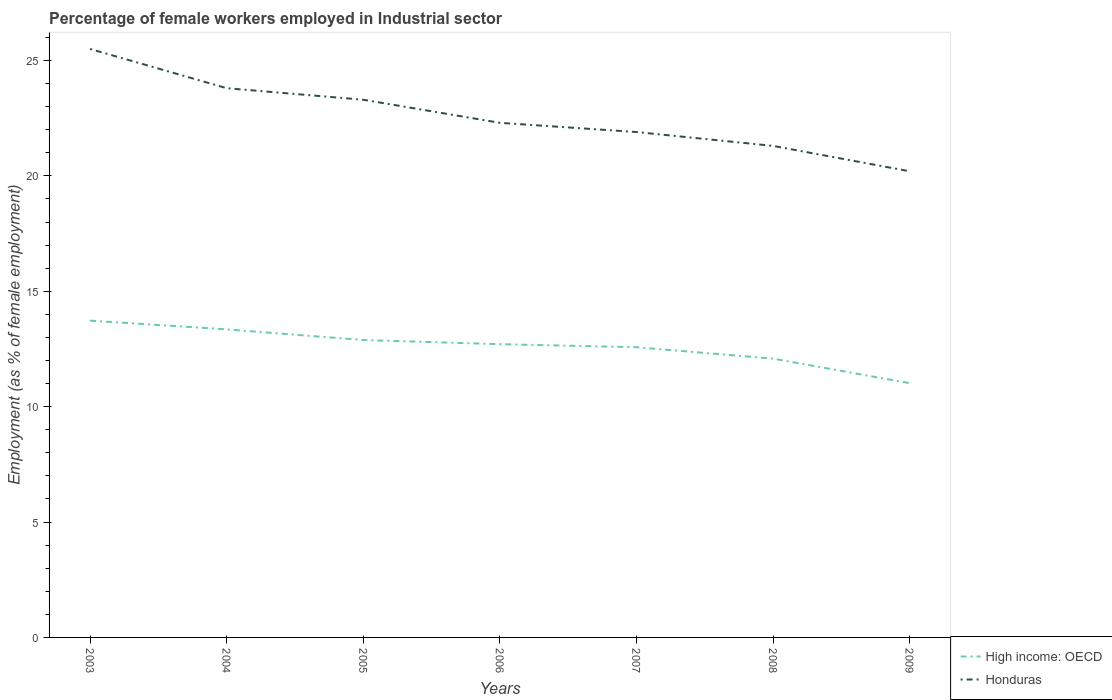How many different coloured lines are there?
Offer a terse response. 2. Is the number of lines equal to the number of legend labels?
Give a very brief answer. Yes. Across all years, what is the maximum percentage of females employed in Industrial sector in Honduras?
Your response must be concise. 20.2. In which year was the percentage of females employed in Industrial sector in High income: OECD maximum?
Provide a short and direct response. 2009. What is the total percentage of females employed in Industrial sector in Honduras in the graph?
Make the answer very short. 4.2. What is the difference between the highest and the second highest percentage of females employed in Industrial sector in High income: OECD?
Ensure brevity in your answer.  2.71. What is the difference between the highest and the lowest percentage of females employed in Industrial sector in High income: OECD?
Keep it short and to the point. 4. How many lines are there?
Make the answer very short. 2. What is the difference between two consecutive major ticks on the Y-axis?
Your answer should be very brief. 5. Where does the legend appear in the graph?
Give a very brief answer. Bottom right. What is the title of the graph?
Give a very brief answer. Percentage of female workers employed in Industrial sector. What is the label or title of the Y-axis?
Provide a short and direct response. Employment (as % of female employment). What is the Employment (as % of female employment) in High income: OECD in 2003?
Your answer should be very brief. 13.73. What is the Employment (as % of female employment) in High income: OECD in 2004?
Make the answer very short. 13.35. What is the Employment (as % of female employment) of Honduras in 2004?
Your response must be concise. 23.8. What is the Employment (as % of female employment) of High income: OECD in 2005?
Ensure brevity in your answer.  12.89. What is the Employment (as % of female employment) in Honduras in 2005?
Make the answer very short. 23.3. What is the Employment (as % of female employment) in High income: OECD in 2006?
Provide a succinct answer. 12.71. What is the Employment (as % of female employment) of Honduras in 2006?
Offer a very short reply. 22.3. What is the Employment (as % of female employment) of High income: OECD in 2007?
Your answer should be very brief. 12.58. What is the Employment (as % of female employment) of Honduras in 2007?
Offer a terse response. 21.9. What is the Employment (as % of female employment) of High income: OECD in 2008?
Offer a terse response. 12.08. What is the Employment (as % of female employment) of Honduras in 2008?
Your answer should be very brief. 21.3. What is the Employment (as % of female employment) in High income: OECD in 2009?
Your response must be concise. 11.02. What is the Employment (as % of female employment) in Honduras in 2009?
Your answer should be very brief. 20.2. Across all years, what is the maximum Employment (as % of female employment) of High income: OECD?
Make the answer very short. 13.73. Across all years, what is the maximum Employment (as % of female employment) in Honduras?
Offer a terse response. 25.5. Across all years, what is the minimum Employment (as % of female employment) of High income: OECD?
Offer a very short reply. 11.02. Across all years, what is the minimum Employment (as % of female employment) of Honduras?
Your answer should be compact. 20.2. What is the total Employment (as % of female employment) of High income: OECD in the graph?
Make the answer very short. 88.34. What is the total Employment (as % of female employment) in Honduras in the graph?
Keep it short and to the point. 158.3. What is the difference between the Employment (as % of female employment) in High income: OECD in 2003 and that in 2004?
Give a very brief answer. 0.38. What is the difference between the Employment (as % of female employment) in Honduras in 2003 and that in 2004?
Provide a succinct answer. 1.7. What is the difference between the Employment (as % of female employment) of High income: OECD in 2003 and that in 2005?
Provide a succinct answer. 0.84. What is the difference between the Employment (as % of female employment) of High income: OECD in 2003 and that in 2006?
Provide a succinct answer. 1.02. What is the difference between the Employment (as % of female employment) in Honduras in 2003 and that in 2006?
Provide a short and direct response. 3.2. What is the difference between the Employment (as % of female employment) of High income: OECD in 2003 and that in 2007?
Your answer should be very brief. 1.15. What is the difference between the Employment (as % of female employment) in Honduras in 2003 and that in 2007?
Make the answer very short. 3.6. What is the difference between the Employment (as % of female employment) in High income: OECD in 2003 and that in 2008?
Ensure brevity in your answer.  1.65. What is the difference between the Employment (as % of female employment) in Honduras in 2003 and that in 2008?
Make the answer very short. 4.2. What is the difference between the Employment (as % of female employment) of High income: OECD in 2003 and that in 2009?
Offer a terse response. 2.71. What is the difference between the Employment (as % of female employment) in Honduras in 2003 and that in 2009?
Ensure brevity in your answer.  5.3. What is the difference between the Employment (as % of female employment) in High income: OECD in 2004 and that in 2005?
Keep it short and to the point. 0.46. What is the difference between the Employment (as % of female employment) in Honduras in 2004 and that in 2005?
Give a very brief answer. 0.5. What is the difference between the Employment (as % of female employment) of High income: OECD in 2004 and that in 2006?
Provide a succinct answer. 0.64. What is the difference between the Employment (as % of female employment) in High income: OECD in 2004 and that in 2007?
Your answer should be compact. 0.77. What is the difference between the Employment (as % of female employment) in Honduras in 2004 and that in 2007?
Keep it short and to the point. 1.9. What is the difference between the Employment (as % of female employment) in High income: OECD in 2004 and that in 2008?
Your answer should be compact. 1.27. What is the difference between the Employment (as % of female employment) of Honduras in 2004 and that in 2008?
Provide a succinct answer. 2.5. What is the difference between the Employment (as % of female employment) of High income: OECD in 2004 and that in 2009?
Ensure brevity in your answer.  2.33. What is the difference between the Employment (as % of female employment) of High income: OECD in 2005 and that in 2006?
Offer a very short reply. 0.18. What is the difference between the Employment (as % of female employment) in High income: OECD in 2005 and that in 2007?
Your answer should be very brief. 0.31. What is the difference between the Employment (as % of female employment) in High income: OECD in 2005 and that in 2008?
Offer a very short reply. 0.81. What is the difference between the Employment (as % of female employment) in Honduras in 2005 and that in 2008?
Your answer should be very brief. 2. What is the difference between the Employment (as % of female employment) of High income: OECD in 2005 and that in 2009?
Offer a terse response. 1.87. What is the difference between the Employment (as % of female employment) of High income: OECD in 2006 and that in 2007?
Offer a very short reply. 0.13. What is the difference between the Employment (as % of female employment) of Honduras in 2006 and that in 2007?
Keep it short and to the point. 0.4. What is the difference between the Employment (as % of female employment) of High income: OECD in 2006 and that in 2008?
Ensure brevity in your answer.  0.63. What is the difference between the Employment (as % of female employment) of High income: OECD in 2006 and that in 2009?
Give a very brief answer. 1.69. What is the difference between the Employment (as % of female employment) in High income: OECD in 2007 and that in 2008?
Your answer should be compact. 0.49. What is the difference between the Employment (as % of female employment) in Honduras in 2007 and that in 2008?
Keep it short and to the point. 0.6. What is the difference between the Employment (as % of female employment) of High income: OECD in 2007 and that in 2009?
Provide a short and direct response. 1.56. What is the difference between the Employment (as % of female employment) in Honduras in 2007 and that in 2009?
Offer a very short reply. 1.7. What is the difference between the Employment (as % of female employment) of High income: OECD in 2008 and that in 2009?
Offer a terse response. 1.06. What is the difference between the Employment (as % of female employment) in Honduras in 2008 and that in 2009?
Your response must be concise. 1.1. What is the difference between the Employment (as % of female employment) in High income: OECD in 2003 and the Employment (as % of female employment) in Honduras in 2004?
Offer a terse response. -10.07. What is the difference between the Employment (as % of female employment) of High income: OECD in 2003 and the Employment (as % of female employment) of Honduras in 2005?
Ensure brevity in your answer.  -9.57. What is the difference between the Employment (as % of female employment) in High income: OECD in 2003 and the Employment (as % of female employment) in Honduras in 2006?
Ensure brevity in your answer.  -8.57. What is the difference between the Employment (as % of female employment) in High income: OECD in 2003 and the Employment (as % of female employment) in Honduras in 2007?
Offer a very short reply. -8.17. What is the difference between the Employment (as % of female employment) in High income: OECD in 2003 and the Employment (as % of female employment) in Honduras in 2008?
Offer a very short reply. -7.57. What is the difference between the Employment (as % of female employment) in High income: OECD in 2003 and the Employment (as % of female employment) in Honduras in 2009?
Provide a succinct answer. -6.47. What is the difference between the Employment (as % of female employment) in High income: OECD in 2004 and the Employment (as % of female employment) in Honduras in 2005?
Ensure brevity in your answer.  -9.95. What is the difference between the Employment (as % of female employment) of High income: OECD in 2004 and the Employment (as % of female employment) of Honduras in 2006?
Give a very brief answer. -8.95. What is the difference between the Employment (as % of female employment) of High income: OECD in 2004 and the Employment (as % of female employment) of Honduras in 2007?
Ensure brevity in your answer.  -8.55. What is the difference between the Employment (as % of female employment) in High income: OECD in 2004 and the Employment (as % of female employment) in Honduras in 2008?
Provide a short and direct response. -7.95. What is the difference between the Employment (as % of female employment) in High income: OECD in 2004 and the Employment (as % of female employment) in Honduras in 2009?
Ensure brevity in your answer.  -6.85. What is the difference between the Employment (as % of female employment) in High income: OECD in 2005 and the Employment (as % of female employment) in Honduras in 2006?
Your answer should be very brief. -9.41. What is the difference between the Employment (as % of female employment) of High income: OECD in 2005 and the Employment (as % of female employment) of Honduras in 2007?
Your answer should be very brief. -9.01. What is the difference between the Employment (as % of female employment) of High income: OECD in 2005 and the Employment (as % of female employment) of Honduras in 2008?
Make the answer very short. -8.41. What is the difference between the Employment (as % of female employment) of High income: OECD in 2005 and the Employment (as % of female employment) of Honduras in 2009?
Your answer should be compact. -7.31. What is the difference between the Employment (as % of female employment) of High income: OECD in 2006 and the Employment (as % of female employment) of Honduras in 2007?
Offer a terse response. -9.19. What is the difference between the Employment (as % of female employment) of High income: OECD in 2006 and the Employment (as % of female employment) of Honduras in 2008?
Keep it short and to the point. -8.59. What is the difference between the Employment (as % of female employment) of High income: OECD in 2006 and the Employment (as % of female employment) of Honduras in 2009?
Provide a succinct answer. -7.49. What is the difference between the Employment (as % of female employment) of High income: OECD in 2007 and the Employment (as % of female employment) of Honduras in 2008?
Offer a terse response. -8.72. What is the difference between the Employment (as % of female employment) of High income: OECD in 2007 and the Employment (as % of female employment) of Honduras in 2009?
Your answer should be compact. -7.62. What is the difference between the Employment (as % of female employment) in High income: OECD in 2008 and the Employment (as % of female employment) in Honduras in 2009?
Make the answer very short. -8.12. What is the average Employment (as % of female employment) of High income: OECD per year?
Give a very brief answer. 12.62. What is the average Employment (as % of female employment) in Honduras per year?
Ensure brevity in your answer.  22.61. In the year 2003, what is the difference between the Employment (as % of female employment) in High income: OECD and Employment (as % of female employment) in Honduras?
Offer a terse response. -11.77. In the year 2004, what is the difference between the Employment (as % of female employment) in High income: OECD and Employment (as % of female employment) in Honduras?
Your response must be concise. -10.45. In the year 2005, what is the difference between the Employment (as % of female employment) in High income: OECD and Employment (as % of female employment) in Honduras?
Offer a very short reply. -10.41. In the year 2006, what is the difference between the Employment (as % of female employment) of High income: OECD and Employment (as % of female employment) of Honduras?
Provide a short and direct response. -9.59. In the year 2007, what is the difference between the Employment (as % of female employment) in High income: OECD and Employment (as % of female employment) in Honduras?
Offer a very short reply. -9.32. In the year 2008, what is the difference between the Employment (as % of female employment) of High income: OECD and Employment (as % of female employment) of Honduras?
Your response must be concise. -9.22. In the year 2009, what is the difference between the Employment (as % of female employment) in High income: OECD and Employment (as % of female employment) in Honduras?
Ensure brevity in your answer.  -9.18. What is the ratio of the Employment (as % of female employment) in High income: OECD in 2003 to that in 2004?
Your answer should be compact. 1.03. What is the ratio of the Employment (as % of female employment) of Honduras in 2003 to that in 2004?
Provide a succinct answer. 1.07. What is the ratio of the Employment (as % of female employment) of High income: OECD in 2003 to that in 2005?
Ensure brevity in your answer.  1.07. What is the ratio of the Employment (as % of female employment) in Honduras in 2003 to that in 2005?
Provide a succinct answer. 1.09. What is the ratio of the Employment (as % of female employment) of High income: OECD in 2003 to that in 2006?
Keep it short and to the point. 1.08. What is the ratio of the Employment (as % of female employment) of Honduras in 2003 to that in 2006?
Offer a very short reply. 1.14. What is the ratio of the Employment (as % of female employment) of High income: OECD in 2003 to that in 2007?
Provide a succinct answer. 1.09. What is the ratio of the Employment (as % of female employment) in Honduras in 2003 to that in 2007?
Offer a terse response. 1.16. What is the ratio of the Employment (as % of female employment) of High income: OECD in 2003 to that in 2008?
Your response must be concise. 1.14. What is the ratio of the Employment (as % of female employment) in Honduras in 2003 to that in 2008?
Offer a very short reply. 1.2. What is the ratio of the Employment (as % of female employment) in High income: OECD in 2003 to that in 2009?
Offer a terse response. 1.25. What is the ratio of the Employment (as % of female employment) in Honduras in 2003 to that in 2009?
Your answer should be compact. 1.26. What is the ratio of the Employment (as % of female employment) in High income: OECD in 2004 to that in 2005?
Your answer should be compact. 1.04. What is the ratio of the Employment (as % of female employment) of Honduras in 2004 to that in 2005?
Your answer should be very brief. 1.02. What is the ratio of the Employment (as % of female employment) in High income: OECD in 2004 to that in 2006?
Provide a succinct answer. 1.05. What is the ratio of the Employment (as % of female employment) in Honduras in 2004 to that in 2006?
Offer a terse response. 1.07. What is the ratio of the Employment (as % of female employment) of High income: OECD in 2004 to that in 2007?
Your response must be concise. 1.06. What is the ratio of the Employment (as % of female employment) in Honduras in 2004 to that in 2007?
Offer a terse response. 1.09. What is the ratio of the Employment (as % of female employment) in High income: OECD in 2004 to that in 2008?
Your answer should be compact. 1.1. What is the ratio of the Employment (as % of female employment) in Honduras in 2004 to that in 2008?
Give a very brief answer. 1.12. What is the ratio of the Employment (as % of female employment) of High income: OECD in 2004 to that in 2009?
Your answer should be very brief. 1.21. What is the ratio of the Employment (as % of female employment) of Honduras in 2004 to that in 2009?
Ensure brevity in your answer.  1.18. What is the ratio of the Employment (as % of female employment) of High income: OECD in 2005 to that in 2006?
Give a very brief answer. 1.01. What is the ratio of the Employment (as % of female employment) of Honduras in 2005 to that in 2006?
Provide a succinct answer. 1.04. What is the ratio of the Employment (as % of female employment) in High income: OECD in 2005 to that in 2007?
Provide a short and direct response. 1.02. What is the ratio of the Employment (as % of female employment) in Honduras in 2005 to that in 2007?
Provide a succinct answer. 1.06. What is the ratio of the Employment (as % of female employment) in High income: OECD in 2005 to that in 2008?
Your response must be concise. 1.07. What is the ratio of the Employment (as % of female employment) in Honduras in 2005 to that in 2008?
Offer a very short reply. 1.09. What is the ratio of the Employment (as % of female employment) of High income: OECD in 2005 to that in 2009?
Your answer should be compact. 1.17. What is the ratio of the Employment (as % of female employment) in Honduras in 2005 to that in 2009?
Your answer should be compact. 1.15. What is the ratio of the Employment (as % of female employment) in High income: OECD in 2006 to that in 2007?
Keep it short and to the point. 1.01. What is the ratio of the Employment (as % of female employment) of Honduras in 2006 to that in 2007?
Ensure brevity in your answer.  1.02. What is the ratio of the Employment (as % of female employment) in High income: OECD in 2006 to that in 2008?
Make the answer very short. 1.05. What is the ratio of the Employment (as % of female employment) of Honduras in 2006 to that in 2008?
Offer a terse response. 1.05. What is the ratio of the Employment (as % of female employment) of High income: OECD in 2006 to that in 2009?
Offer a very short reply. 1.15. What is the ratio of the Employment (as % of female employment) of Honduras in 2006 to that in 2009?
Keep it short and to the point. 1.1. What is the ratio of the Employment (as % of female employment) of High income: OECD in 2007 to that in 2008?
Your answer should be very brief. 1.04. What is the ratio of the Employment (as % of female employment) of Honduras in 2007 to that in 2008?
Provide a short and direct response. 1.03. What is the ratio of the Employment (as % of female employment) in High income: OECD in 2007 to that in 2009?
Ensure brevity in your answer.  1.14. What is the ratio of the Employment (as % of female employment) of Honduras in 2007 to that in 2009?
Offer a very short reply. 1.08. What is the ratio of the Employment (as % of female employment) in High income: OECD in 2008 to that in 2009?
Offer a terse response. 1.1. What is the ratio of the Employment (as % of female employment) in Honduras in 2008 to that in 2009?
Provide a succinct answer. 1.05. What is the difference between the highest and the second highest Employment (as % of female employment) in High income: OECD?
Keep it short and to the point. 0.38. What is the difference between the highest and the second highest Employment (as % of female employment) of Honduras?
Ensure brevity in your answer.  1.7. What is the difference between the highest and the lowest Employment (as % of female employment) in High income: OECD?
Give a very brief answer. 2.71. What is the difference between the highest and the lowest Employment (as % of female employment) in Honduras?
Provide a short and direct response. 5.3. 